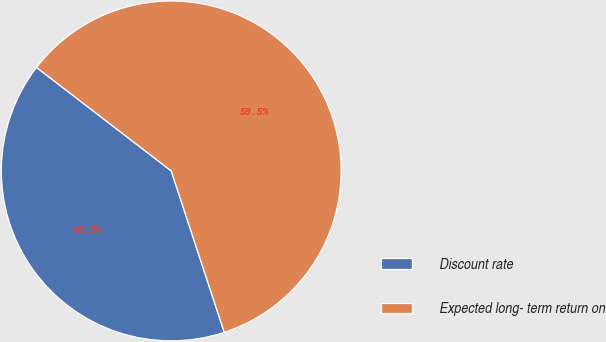Convert chart. <chart><loc_0><loc_0><loc_500><loc_500><pie_chart><fcel>Discount rate<fcel>Expected long- term return on<nl><fcel>40.48%<fcel>59.52%<nl></chart> 